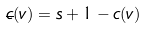Convert formula to latex. <formula><loc_0><loc_0><loc_500><loc_500>\overline { c } ( v ) = s + 1 - c ( v )</formula> 